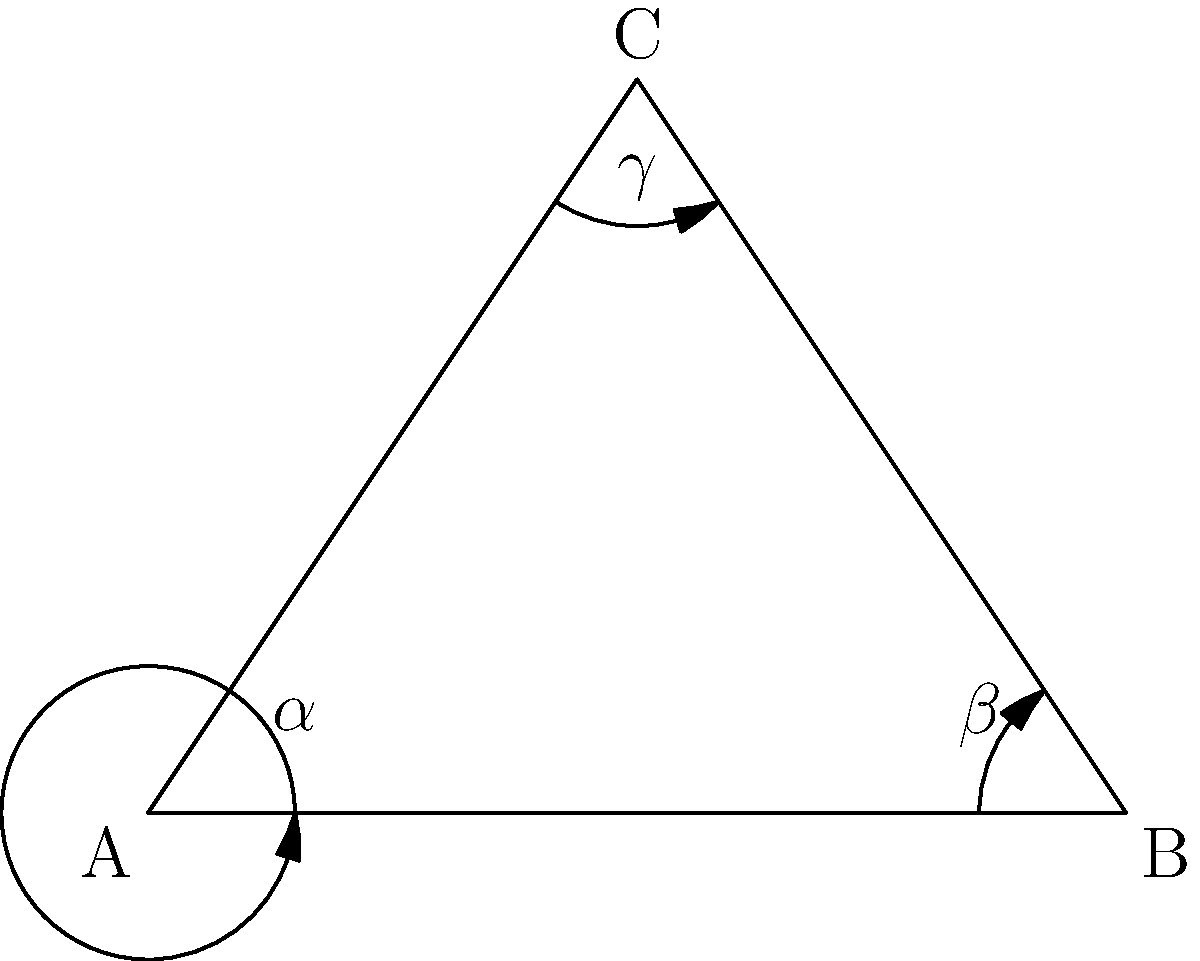In a hyperbolic triangle ABC, the angles are denoted as $\alpha$, $\beta$, and $\gamma$. Which of the following statements is true about the sum of these angles in hyperbolic geometry?

a) $\alpha + \beta + \gamma = 180°$
b) $\alpha + \beta + \gamma > 180°$
c) $\alpha + \beta + \gamma < 180°$
d) $\alpha + \beta + \gamma$ is always equal to a constant value other than 180° To answer this question, let's consider the properties of hyperbolic geometry:

1. In Euclidean geometry, the sum of angles in a triangle is always 180°. However, hyperbolic geometry differs from Euclidean geometry in its parallel postulate.

2. In hyperbolic geometry, through a point not on a given line, there are at least two lines parallel to the given line. This leads to significant differences in the properties of triangles.

3. One of the key differences is that the sum of angles in a hyperbolic triangle is always less than 180°. This is known as the hyperbolic angle defect.

4. The angle defect in a hyperbolic triangle is directly related to its area. The larger the triangle, the smaller the sum of its angles.

5. As the size of a hyperbolic triangle approaches zero, the sum of its angles approaches 180°, but never reaches or exceeds it.

6. This property is consistent across all hyperbolic triangles, regardless of their size or shape.

Therefore, in hyperbolic geometry, the sum of angles in a triangle ABC ($\alpha + \beta + \gamma$) is always less than 180°.
Answer: c) $\alpha + \beta + \gamma < 180°$ 